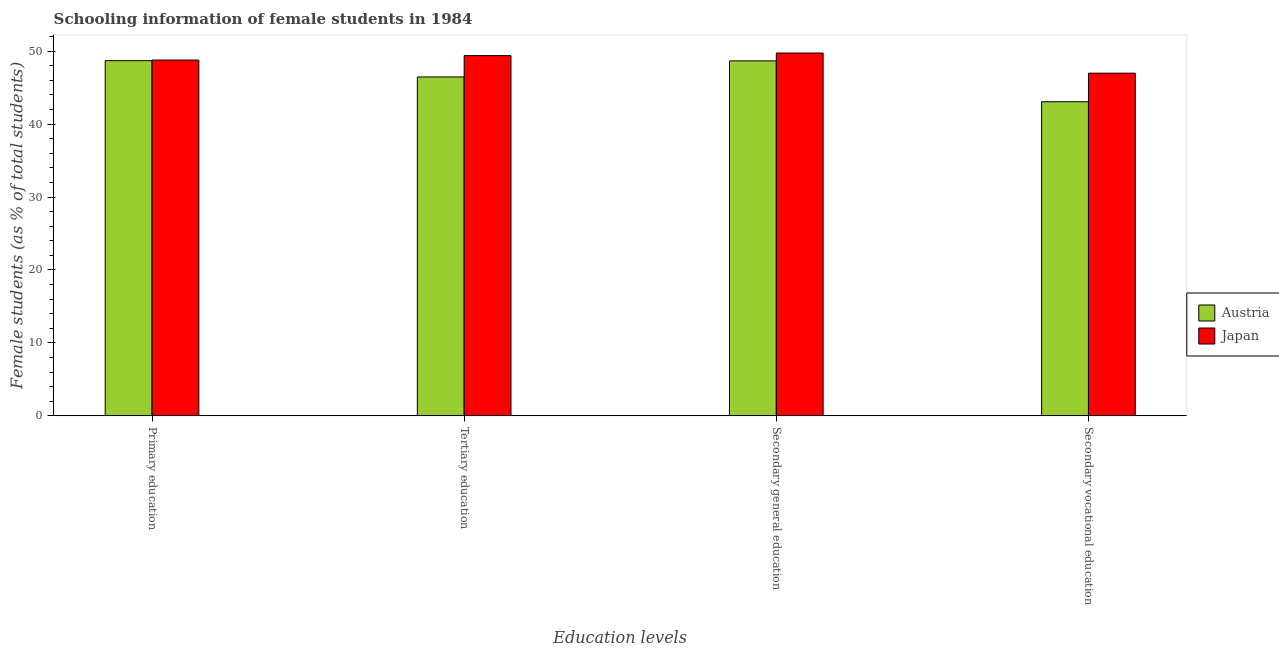Are the number of bars per tick equal to the number of legend labels?
Make the answer very short. Yes. Are the number of bars on each tick of the X-axis equal?
Your answer should be very brief. Yes. How many bars are there on the 2nd tick from the right?
Ensure brevity in your answer.  2. What is the label of the 4th group of bars from the left?
Your response must be concise. Secondary vocational education. What is the percentage of female students in tertiary education in Japan?
Your answer should be compact. 49.38. Across all countries, what is the maximum percentage of female students in secondary vocational education?
Your answer should be very brief. 46.98. Across all countries, what is the minimum percentage of female students in tertiary education?
Provide a short and direct response. 46.46. In which country was the percentage of female students in secondary education minimum?
Your answer should be compact. Austria. What is the total percentage of female students in secondary vocational education in the graph?
Offer a very short reply. 90.04. What is the difference between the percentage of female students in primary education in Japan and that in Austria?
Provide a succinct answer. 0.08. What is the difference between the percentage of female students in secondary education in Austria and the percentage of female students in secondary vocational education in Japan?
Your response must be concise. 1.69. What is the average percentage of female students in tertiary education per country?
Keep it short and to the point. 47.92. What is the difference between the percentage of female students in tertiary education and percentage of female students in secondary education in Japan?
Offer a terse response. -0.36. In how many countries, is the percentage of female students in secondary education greater than 12 %?
Give a very brief answer. 2. What is the ratio of the percentage of female students in secondary vocational education in Japan to that in Austria?
Keep it short and to the point. 1.09. What is the difference between the highest and the second highest percentage of female students in secondary vocational education?
Make the answer very short. 3.91. What is the difference between the highest and the lowest percentage of female students in primary education?
Keep it short and to the point. 0.08. Is the sum of the percentage of female students in secondary vocational education in Austria and Japan greater than the maximum percentage of female students in secondary education across all countries?
Ensure brevity in your answer.  Yes. What does the 2nd bar from the left in Tertiary education represents?
Your answer should be compact. Japan. What does the 1st bar from the right in Secondary general education represents?
Give a very brief answer. Japan. Is it the case that in every country, the sum of the percentage of female students in primary education and percentage of female students in tertiary education is greater than the percentage of female students in secondary education?
Your answer should be compact. Yes. How many bars are there?
Provide a succinct answer. 8. How many countries are there in the graph?
Give a very brief answer. 2. Does the graph contain grids?
Keep it short and to the point. No. What is the title of the graph?
Keep it short and to the point. Schooling information of female students in 1984. What is the label or title of the X-axis?
Provide a succinct answer. Education levels. What is the label or title of the Y-axis?
Your response must be concise. Female students (as % of total students). What is the Female students (as % of total students) in Austria in Primary education?
Offer a terse response. 48.69. What is the Female students (as % of total students) in Japan in Primary education?
Offer a terse response. 48.77. What is the Female students (as % of total students) in Austria in Tertiary education?
Make the answer very short. 46.46. What is the Female students (as % of total students) in Japan in Tertiary education?
Make the answer very short. 49.38. What is the Female students (as % of total students) of Austria in Secondary general education?
Ensure brevity in your answer.  48.67. What is the Female students (as % of total students) in Japan in Secondary general education?
Offer a very short reply. 49.74. What is the Female students (as % of total students) in Austria in Secondary vocational education?
Keep it short and to the point. 43.06. What is the Female students (as % of total students) in Japan in Secondary vocational education?
Your answer should be compact. 46.98. Across all Education levels, what is the maximum Female students (as % of total students) of Austria?
Keep it short and to the point. 48.69. Across all Education levels, what is the maximum Female students (as % of total students) in Japan?
Offer a very short reply. 49.74. Across all Education levels, what is the minimum Female students (as % of total students) of Austria?
Offer a very short reply. 43.06. Across all Education levels, what is the minimum Female students (as % of total students) of Japan?
Offer a very short reply. 46.98. What is the total Female students (as % of total students) in Austria in the graph?
Your answer should be compact. 186.88. What is the total Female students (as % of total students) of Japan in the graph?
Offer a very short reply. 194.88. What is the difference between the Female students (as % of total students) of Austria in Primary education and that in Tertiary education?
Provide a short and direct response. 2.23. What is the difference between the Female students (as % of total students) of Japan in Primary education and that in Tertiary education?
Provide a short and direct response. -0.61. What is the difference between the Female students (as % of total students) of Austria in Primary education and that in Secondary general education?
Provide a succinct answer. 0.03. What is the difference between the Female students (as % of total students) of Japan in Primary education and that in Secondary general education?
Offer a terse response. -0.97. What is the difference between the Female students (as % of total students) in Austria in Primary education and that in Secondary vocational education?
Offer a very short reply. 5.63. What is the difference between the Female students (as % of total students) in Japan in Primary education and that in Secondary vocational education?
Keep it short and to the point. 1.8. What is the difference between the Female students (as % of total students) in Austria in Tertiary education and that in Secondary general education?
Ensure brevity in your answer.  -2.21. What is the difference between the Female students (as % of total students) in Japan in Tertiary education and that in Secondary general education?
Ensure brevity in your answer.  -0.36. What is the difference between the Female students (as % of total students) of Austria in Tertiary education and that in Secondary vocational education?
Give a very brief answer. 3.4. What is the difference between the Female students (as % of total students) of Japan in Tertiary education and that in Secondary vocational education?
Your response must be concise. 2.41. What is the difference between the Female students (as % of total students) in Austria in Secondary general education and that in Secondary vocational education?
Provide a short and direct response. 5.6. What is the difference between the Female students (as % of total students) of Japan in Secondary general education and that in Secondary vocational education?
Keep it short and to the point. 2.76. What is the difference between the Female students (as % of total students) in Austria in Primary education and the Female students (as % of total students) in Japan in Tertiary education?
Provide a short and direct response. -0.69. What is the difference between the Female students (as % of total students) in Austria in Primary education and the Female students (as % of total students) in Japan in Secondary general education?
Ensure brevity in your answer.  -1.05. What is the difference between the Female students (as % of total students) of Austria in Primary education and the Female students (as % of total students) of Japan in Secondary vocational education?
Keep it short and to the point. 1.72. What is the difference between the Female students (as % of total students) in Austria in Tertiary education and the Female students (as % of total students) in Japan in Secondary general education?
Your answer should be very brief. -3.28. What is the difference between the Female students (as % of total students) in Austria in Tertiary education and the Female students (as % of total students) in Japan in Secondary vocational education?
Your answer should be compact. -0.52. What is the difference between the Female students (as % of total students) of Austria in Secondary general education and the Female students (as % of total students) of Japan in Secondary vocational education?
Give a very brief answer. 1.69. What is the average Female students (as % of total students) in Austria per Education levels?
Offer a very short reply. 46.72. What is the average Female students (as % of total students) of Japan per Education levels?
Your response must be concise. 48.72. What is the difference between the Female students (as % of total students) in Austria and Female students (as % of total students) in Japan in Primary education?
Provide a succinct answer. -0.08. What is the difference between the Female students (as % of total students) in Austria and Female students (as % of total students) in Japan in Tertiary education?
Ensure brevity in your answer.  -2.92. What is the difference between the Female students (as % of total students) of Austria and Female students (as % of total students) of Japan in Secondary general education?
Keep it short and to the point. -1.08. What is the difference between the Female students (as % of total students) of Austria and Female students (as % of total students) of Japan in Secondary vocational education?
Keep it short and to the point. -3.91. What is the ratio of the Female students (as % of total students) in Austria in Primary education to that in Tertiary education?
Your answer should be very brief. 1.05. What is the ratio of the Female students (as % of total students) of Japan in Primary education to that in Tertiary education?
Your answer should be compact. 0.99. What is the ratio of the Female students (as % of total students) of Austria in Primary education to that in Secondary general education?
Offer a terse response. 1. What is the ratio of the Female students (as % of total students) in Japan in Primary education to that in Secondary general education?
Provide a short and direct response. 0.98. What is the ratio of the Female students (as % of total students) of Austria in Primary education to that in Secondary vocational education?
Your answer should be very brief. 1.13. What is the ratio of the Female students (as % of total students) of Japan in Primary education to that in Secondary vocational education?
Provide a succinct answer. 1.04. What is the ratio of the Female students (as % of total students) of Austria in Tertiary education to that in Secondary general education?
Your response must be concise. 0.95. What is the ratio of the Female students (as % of total students) of Japan in Tertiary education to that in Secondary general education?
Give a very brief answer. 0.99. What is the ratio of the Female students (as % of total students) of Austria in Tertiary education to that in Secondary vocational education?
Offer a terse response. 1.08. What is the ratio of the Female students (as % of total students) of Japan in Tertiary education to that in Secondary vocational education?
Provide a succinct answer. 1.05. What is the ratio of the Female students (as % of total students) in Austria in Secondary general education to that in Secondary vocational education?
Your response must be concise. 1.13. What is the ratio of the Female students (as % of total students) in Japan in Secondary general education to that in Secondary vocational education?
Ensure brevity in your answer.  1.06. What is the difference between the highest and the second highest Female students (as % of total students) in Austria?
Ensure brevity in your answer.  0.03. What is the difference between the highest and the second highest Female students (as % of total students) in Japan?
Your answer should be compact. 0.36. What is the difference between the highest and the lowest Female students (as % of total students) of Austria?
Keep it short and to the point. 5.63. What is the difference between the highest and the lowest Female students (as % of total students) in Japan?
Keep it short and to the point. 2.76. 